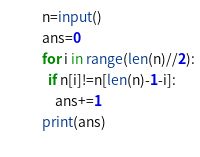Convert code to text. <code><loc_0><loc_0><loc_500><loc_500><_Python_>n=input()
ans=0
for i in range(len(n)//2):
  if n[i]!=n[len(n)-1-i]:
    ans+=1
print(ans)
  </code> 